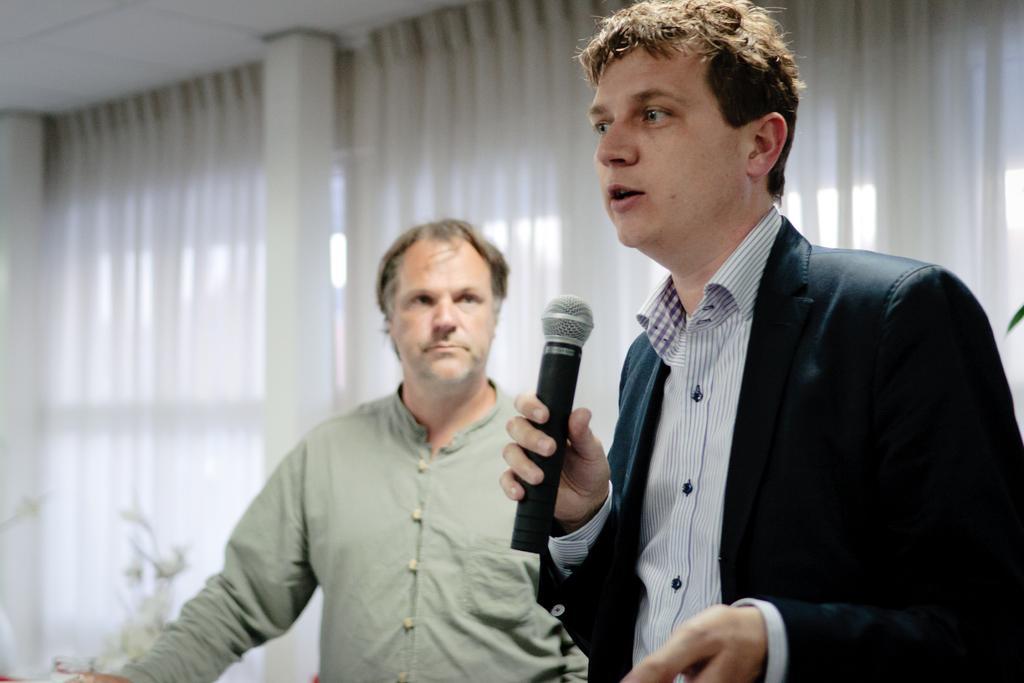Describe this image in one or two sentences. As we can see in the image there are white color curtains and two people standing over here. The man on the right side is holding mic in his hand. 